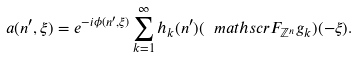<formula> <loc_0><loc_0><loc_500><loc_500>a ( n ^ { \prime } , \xi ) = e ^ { - i \phi ( n ^ { \prime } , \xi ) } \sum _ { k = 1 } ^ { \infty } h _ { k } ( n ^ { \prime } ) ( \ m a t h s c r { F } _ { \mathbb { Z } ^ { n } } { g } _ { k } ) ( - \xi ) .</formula> 